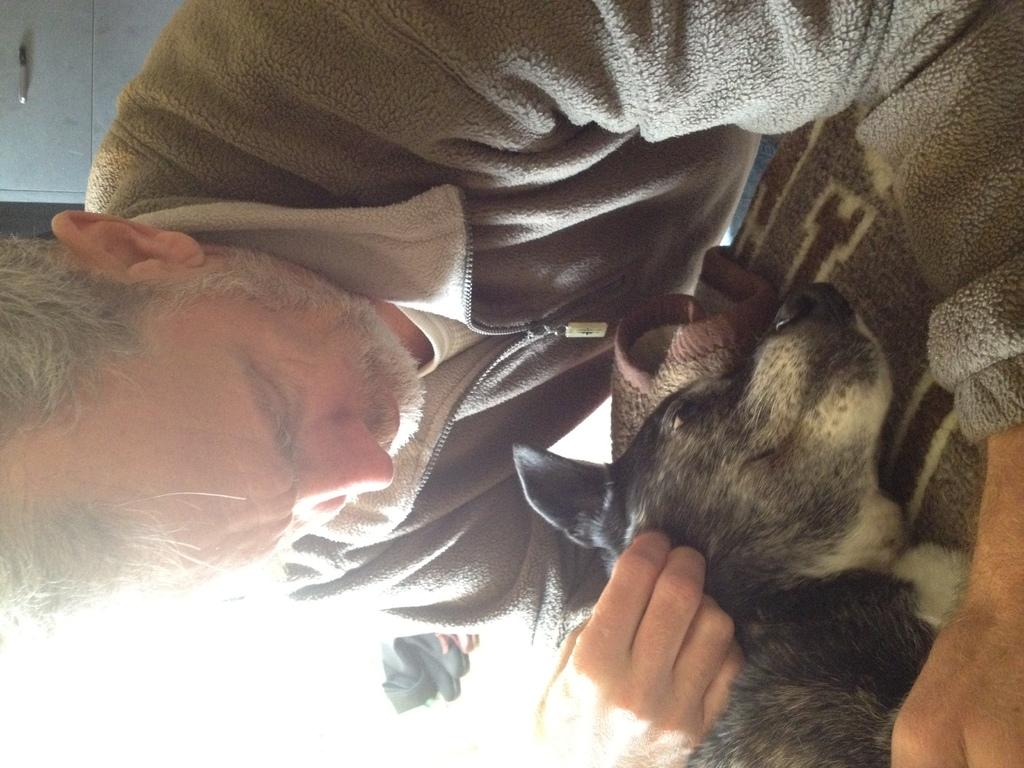What is the main subject of the image? There is a person in the image. What is the person wearing? The person is wearing a sweater. What is the person doing with the dog? The person is pampering a dog. What is the position of the dog in the image? The dog is lying on a surface. What can be seen in the background of the image? There is a cupboard in the background of the image. What type of nail is being used to rub the dog in the image? There is no nail or rubbing action present in the image; the person is pampering the dog, which typically involves gentle stroking or petting. 